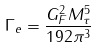<formula> <loc_0><loc_0><loc_500><loc_500>\Gamma _ { e } = \frac { G _ { F } ^ { 2 } M _ { \tau } ^ { 5 } } { 1 9 2 \pi ^ { 3 } }</formula> 